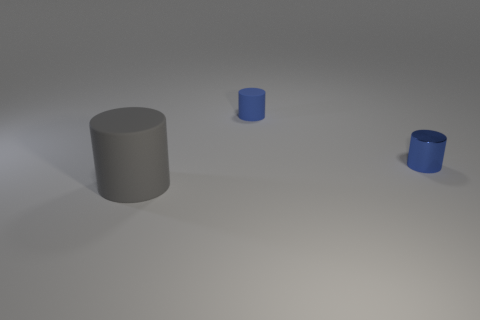Are there any other metal cylinders of the same color as the small metal cylinder?
Give a very brief answer. No. There is a cylinder that is behind the tiny blue metal cylinder; is its color the same as the large rubber object?
Provide a short and direct response. No. How many objects are matte cylinders behind the gray cylinder or tiny rubber cylinders?
Your answer should be very brief. 1. There is a tiny metallic cylinder; are there any matte cylinders right of it?
Your answer should be compact. No. What material is the other cylinder that is the same color as the tiny shiny cylinder?
Ensure brevity in your answer.  Rubber. Are the tiny blue cylinder that is to the right of the small blue rubber thing and the big object made of the same material?
Your answer should be very brief. No. There is a blue object right of the blue cylinder that is behind the tiny blue shiny thing; is there a large thing that is on the left side of it?
Give a very brief answer. Yes. What number of cylinders are either tiny shiny objects or small blue objects?
Offer a terse response. 2. What material is the small blue cylinder to the right of the blue rubber cylinder?
Give a very brief answer. Metal. There is a metal cylinder that is the same color as the tiny rubber cylinder; what is its size?
Keep it short and to the point. Small. 